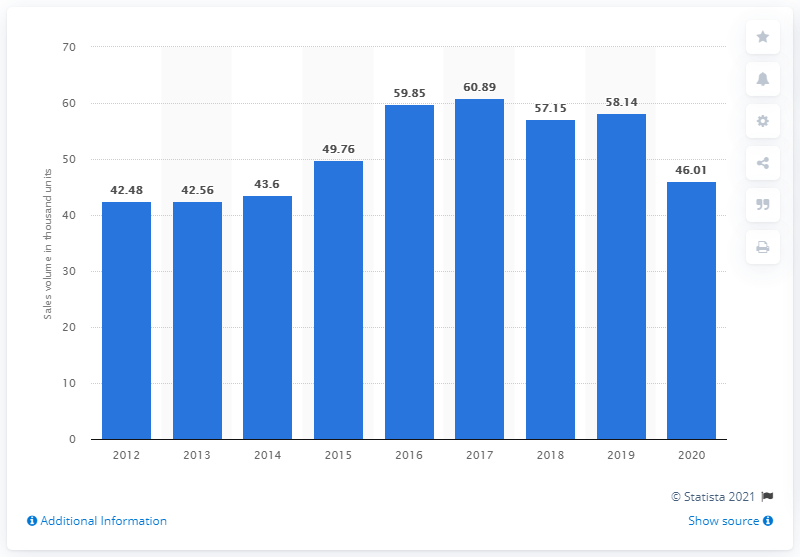Mention a couple of crucial points in this snapshot. BMW's sales volume was the lowest in 2014. 